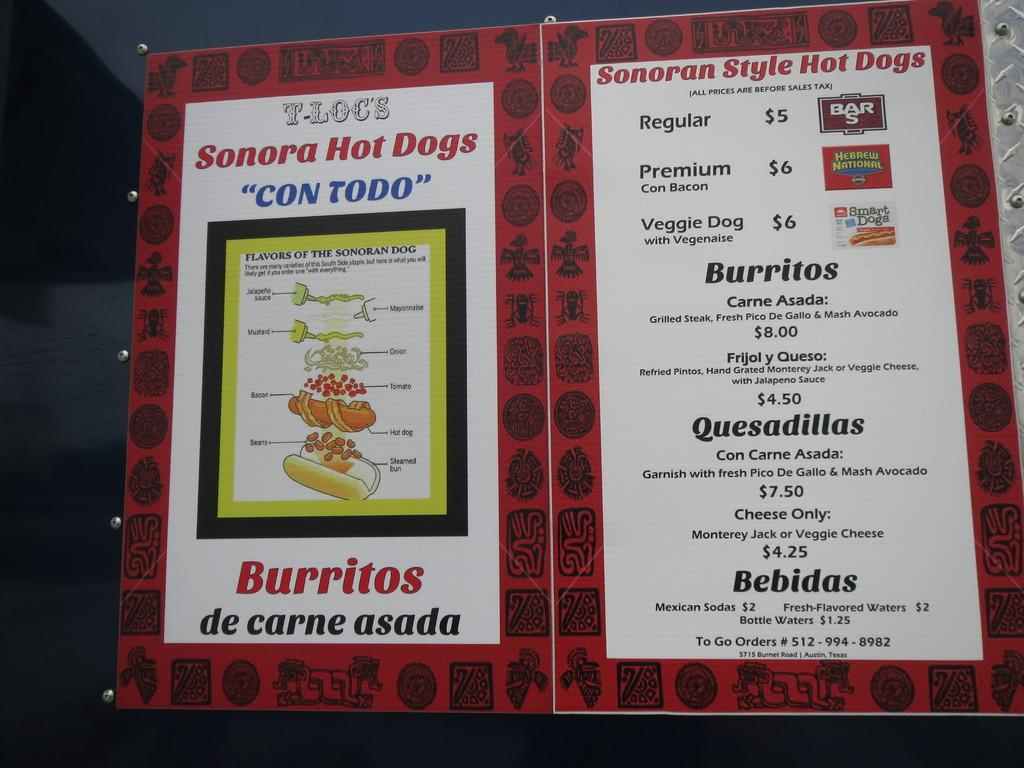<image>
Present a compact description of the photo's key features. a menu that says 'burritos de carne asada' on it 